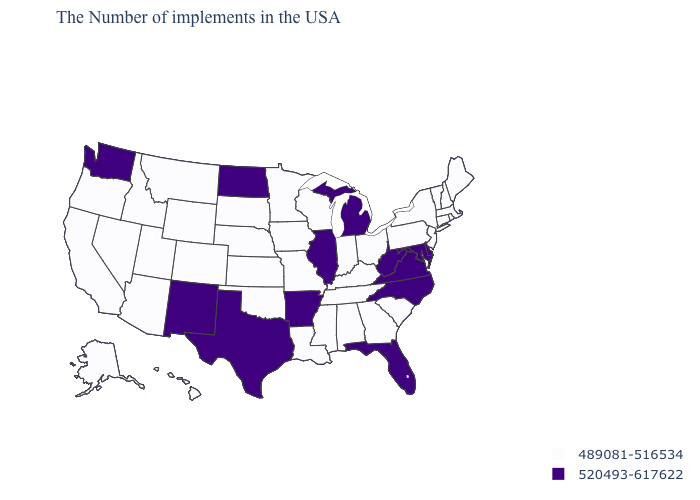What is the value of Florida?
Keep it brief. 520493-617622. Name the states that have a value in the range 489081-516534?
Give a very brief answer. Maine, Massachusetts, Rhode Island, New Hampshire, Vermont, Connecticut, New York, New Jersey, Pennsylvania, South Carolina, Ohio, Georgia, Kentucky, Indiana, Alabama, Tennessee, Wisconsin, Mississippi, Louisiana, Missouri, Minnesota, Iowa, Kansas, Nebraska, Oklahoma, South Dakota, Wyoming, Colorado, Utah, Montana, Arizona, Idaho, Nevada, California, Oregon, Alaska, Hawaii. Name the states that have a value in the range 520493-617622?
Answer briefly. Delaware, Maryland, Virginia, North Carolina, West Virginia, Florida, Michigan, Illinois, Arkansas, Texas, North Dakota, New Mexico, Washington. Does the map have missing data?
Write a very short answer. No. Name the states that have a value in the range 489081-516534?
Be succinct. Maine, Massachusetts, Rhode Island, New Hampshire, Vermont, Connecticut, New York, New Jersey, Pennsylvania, South Carolina, Ohio, Georgia, Kentucky, Indiana, Alabama, Tennessee, Wisconsin, Mississippi, Louisiana, Missouri, Minnesota, Iowa, Kansas, Nebraska, Oklahoma, South Dakota, Wyoming, Colorado, Utah, Montana, Arizona, Idaho, Nevada, California, Oregon, Alaska, Hawaii. Name the states that have a value in the range 520493-617622?
Keep it brief. Delaware, Maryland, Virginia, North Carolina, West Virginia, Florida, Michigan, Illinois, Arkansas, Texas, North Dakota, New Mexico, Washington. How many symbols are there in the legend?
Quick response, please. 2. What is the highest value in states that border Maryland?
Be succinct. 520493-617622. What is the value of Iowa?
Short answer required. 489081-516534. What is the lowest value in states that border New Jersey?
Answer briefly. 489081-516534. What is the value of Nevada?
Be succinct. 489081-516534. Among the states that border Oregon , which have the lowest value?
Keep it brief. Idaho, Nevada, California. What is the highest value in the USA?
Write a very short answer. 520493-617622. Does Washington have the highest value in the West?
Short answer required. Yes. 